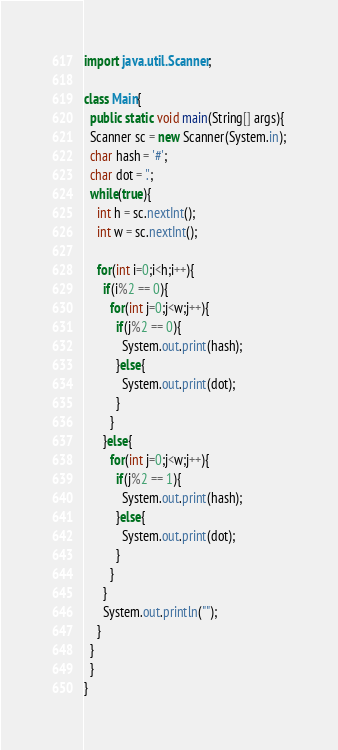<code> <loc_0><loc_0><loc_500><loc_500><_Java_>import java.util.Scanner;

class Main{
  public static void main(String[] args){
  Scanner sc = new Scanner(System.in);
  char hash = '#';
  char dot = '.';
  while(true){
    int h = sc.nextInt();
    int w = sc.nextInt();

    for(int i=0;i<h;i++){
      if(i%2 == 0){
        for(int j=0;j<w;j++){
          if(j%2 == 0){
            System.out.print(hash);
          }else{
            System.out.print(dot);
          }
        }
      }else{
        for(int j=0;j<w;j++){
          if(j%2 == 1){
            System.out.print(hash);
          }else{
            System.out.print(dot);
          }
        }
      }
      System.out.println("");
    }
  }
  }
}</code> 